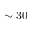Convert formula to latex. <formula><loc_0><loc_0><loc_500><loc_500>\sim 3 0</formula> 